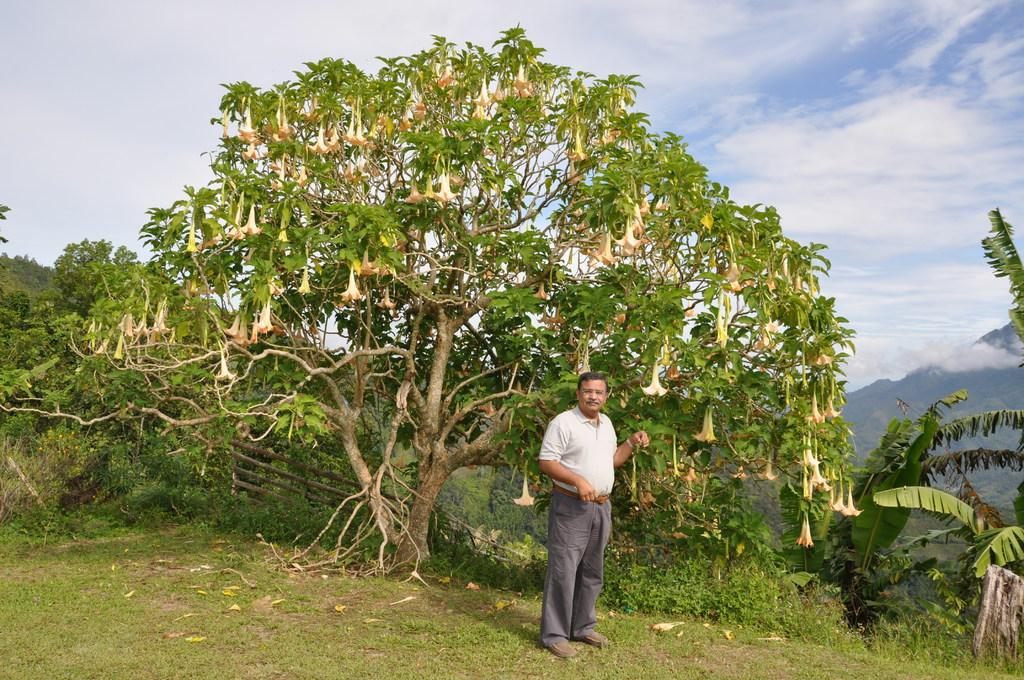What is the main subject of the image? There is a man standing in the image. Where is the man standing? The man is standing on grass. What type of vegetation can be seen in the image? There are flowers and trees visible in the image. What objects can be seen on the ground in the image? There are sticks in the image. What is visible in the background of the image? There are mountains and the sky visible in the background of the image. What is the condition of the sky in the image? Clouds are present in the sky. What type of cent is visible in the image? There is no cent present in the image. What type of club is the man holding in the image? The man is not holding any club in the image. 